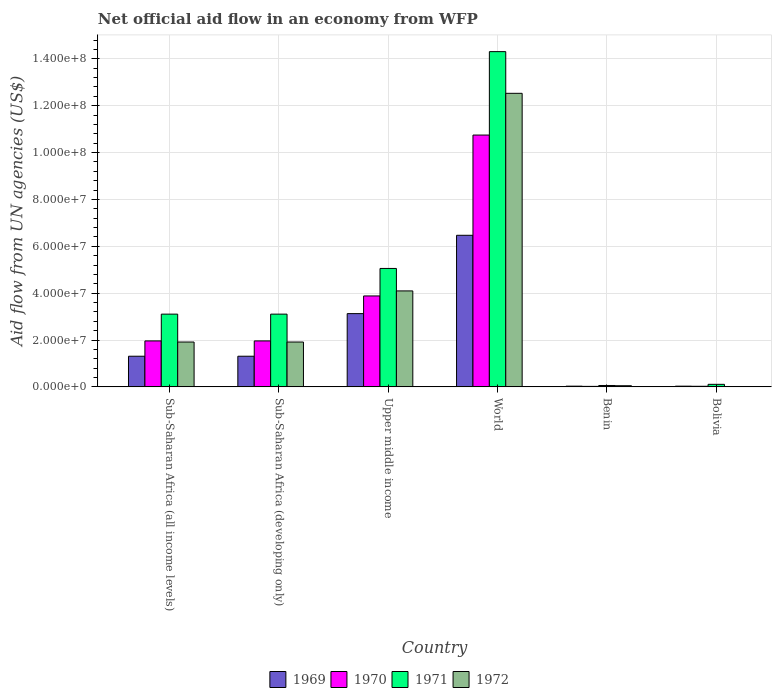How many different coloured bars are there?
Keep it short and to the point. 4. How many groups of bars are there?
Offer a very short reply. 6. Are the number of bars per tick equal to the number of legend labels?
Offer a terse response. No. What is the label of the 2nd group of bars from the left?
Offer a terse response. Sub-Saharan Africa (developing only). What is the net official aid flow in 1970 in Upper middle income?
Ensure brevity in your answer.  3.88e+07. Across all countries, what is the maximum net official aid flow in 1970?
Offer a very short reply. 1.07e+08. In which country was the net official aid flow in 1970 maximum?
Provide a succinct answer. World. What is the total net official aid flow in 1970 in the graph?
Provide a short and direct response. 1.86e+08. What is the difference between the net official aid flow in 1970 in Sub-Saharan Africa (developing only) and that in Upper middle income?
Ensure brevity in your answer.  -1.92e+07. What is the difference between the net official aid flow in 1972 in Benin and the net official aid flow in 1971 in Upper middle income?
Your answer should be compact. -5.00e+07. What is the average net official aid flow in 1969 per country?
Offer a very short reply. 2.05e+07. What is the difference between the net official aid flow of/in 1971 and net official aid flow of/in 1972 in Benin?
Give a very brief answer. 1.00e+05. What is the ratio of the net official aid flow in 1969 in Bolivia to that in Sub-Saharan Africa (all income levels)?
Provide a short and direct response. 0.02. Is the difference between the net official aid flow in 1971 in Benin and World greater than the difference between the net official aid flow in 1972 in Benin and World?
Ensure brevity in your answer.  No. What is the difference between the highest and the second highest net official aid flow in 1969?
Your answer should be very brief. 3.34e+07. What is the difference between the highest and the lowest net official aid flow in 1972?
Ensure brevity in your answer.  1.25e+08. Is the sum of the net official aid flow in 1969 in Benin and World greater than the maximum net official aid flow in 1972 across all countries?
Ensure brevity in your answer.  No. Is it the case that in every country, the sum of the net official aid flow in 1971 and net official aid flow in 1972 is greater than the sum of net official aid flow in 1969 and net official aid flow in 1970?
Your response must be concise. No. How many bars are there?
Offer a very short reply. 23. Are all the bars in the graph horizontal?
Offer a terse response. No. How many countries are there in the graph?
Offer a terse response. 6. What is the difference between two consecutive major ticks on the Y-axis?
Your answer should be compact. 2.00e+07. Are the values on the major ticks of Y-axis written in scientific E-notation?
Offer a terse response. Yes. Does the graph contain any zero values?
Keep it short and to the point. Yes. What is the title of the graph?
Keep it short and to the point. Net official aid flow in an economy from WFP. Does "1978" appear as one of the legend labels in the graph?
Your answer should be compact. No. What is the label or title of the X-axis?
Keep it short and to the point. Country. What is the label or title of the Y-axis?
Provide a short and direct response. Aid flow from UN agencies (US$). What is the Aid flow from UN agencies (US$) in 1969 in Sub-Saharan Africa (all income levels)?
Provide a succinct answer. 1.31e+07. What is the Aid flow from UN agencies (US$) of 1970 in Sub-Saharan Africa (all income levels)?
Make the answer very short. 1.96e+07. What is the Aid flow from UN agencies (US$) in 1971 in Sub-Saharan Africa (all income levels)?
Your answer should be compact. 3.10e+07. What is the Aid flow from UN agencies (US$) of 1972 in Sub-Saharan Africa (all income levels)?
Provide a succinct answer. 1.91e+07. What is the Aid flow from UN agencies (US$) of 1969 in Sub-Saharan Africa (developing only)?
Make the answer very short. 1.31e+07. What is the Aid flow from UN agencies (US$) in 1970 in Sub-Saharan Africa (developing only)?
Your response must be concise. 1.96e+07. What is the Aid flow from UN agencies (US$) of 1971 in Sub-Saharan Africa (developing only)?
Provide a succinct answer. 3.10e+07. What is the Aid flow from UN agencies (US$) in 1972 in Sub-Saharan Africa (developing only)?
Ensure brevity in your answer.  1.91e+07. What is the Aid flow from UN agencies (US$) in 1969 in Upper middle income?
Your answer should be very brief. 3.13e+07. What is the Aid flow from UN agencies (US$) in 1970 in Upper middle income?
Your answer should be compact. 3.88e+07. What is the Aid flow from UN agencies (US$) in 1971 in Upper middle income?
Offer a very short reply. 5.05e+07. What is the Aid flow from UN agencies (US$) in 1972 in Upper middle income?
Provide a succinct answer. 4.10e+07. What is the Aid flow from UN agencies (US$) of 1969 in World?
Offer a very short reply. 6.47e+07. What is the Aid flow from UN agencies (US$) in 1970 in World?
Your answer should be compact. 1.07e+08. What is the Aid flow from UN agencies (US$) in 1971 in World?
Give a very brief answer. 1.43e+08. What is the Aid flow from UN agencies (US$) in 1972 in World?
Your answer should be compact. 1.25e+08. What is the Aid flow from UN agencies (US$) of 1971 in Benin?
Keep it short and to the point. 5.90e+05. What is the Aid flow from UN agencies (US$) of 1969 in Bolivia?
Make the answer very short. 3.00e+05. What is the Aid flow from UN agencies (US$) in 1970 in Bolivia?
Keep it short and to the point. 2.50e+05. What is the Aid flow from UN agencies (US$) of 1971 in Bolivia?
Provide a succinct answer. 1.08e+06. Across all countries, what is the maximum Aid flow from UN agencies (US$) in 1969?
Your answer should be compact. 6.47e+07. Across all countries, what is the maximum Aid flow from UN agencies (US$) in 1970?
Your answer should be compact. 1.07e+08. Across all countries, what is the maximum Aid flow from UN agencies (US$) of 1971?
Your answer should be very brief. 1.43e+08. Across all countries, what is the maximum Aid flow from UN agencies (US$) of 1972?
Keep it short and to the point. 1.25e+08. Across all countries, what is the minimum Aid flow from UN agencies (US$) in 1971?
Your response must be concise. 5.90e+05. What is the total Aid flow from UN agencies (US$) of 1969 in the graph?
Give a very brief answer. 1.23e+08. What is the total Aid flow from UN agencies (US$) of 1970 in the graph?
Your answer should be compact. 1.86e+08. What is the total Aid flow from UN agencies (US$) in 1971 in the graph?
Keep it short and to the point. 2.57e+08. What is the total Aid flow from UN agencies (US$) in 1972 in the graph?
Provide a succinct answer. 2.05e+08. What is the difference between the Aid flow from UN agencies (US$) of 1970 in Sub-Saharan Africa (all income levels) and that in Sub-Saharan Africa (developing only)?
Make the answer very short. 0. What is the difference between the Aid flow from UN agencies (US$) in 1971 in Sub-Saharan Africa (all income levels) and that in Sub-Saharan Africa (developing only)?
Keep it short and to the point. 0. What is the difference between the Aid flow from UN agencies (US$) of 1969 in Sub-Saharan Africa (all income levels) and that in Upper middle income?
Ensure brevity in your answer.  -1.82e+07. What is the difference between the Aid flow from UN agencies (US$) in 1970 in Sub-Saharan Africa (all income levels) and that in Upper middle income?
Offer a terse response. -1.92e+07. What is the difference between the Aid flow from UN agencies (US$) in 1971 in Sub-Saharan Africa (all income levels) and that in Upper middle income?
Your answer should be compact. -1.95e+07. What is the difference between the Aid flow from UN agencies (US$) of 1972 in Sub-Saharan Africa (all income levels) and that in Upper middle income?
Make the answer very short. -2.18e+07. What is the difference between the Aid flow from UN agencies (US$) of 1969 in Sub-Saharan Africa (all income levels) and that in World?
Give a very brief answer. -5.16e+07. What is the difference between the Aid flow from UN agencies (US$) in 1970 in Sub-Saharan Africa (all income levels) and that in World?
Provide a succinct answer. -8.78e+07. What is the difference between the Aid flow from UN agencies (US$) of 1971 in Sub-Saharan Africa (all income levels) and that in World?
Your answer should be very brief. -1.12e+08. What is the difference between the Aid flow from UN agencies (US$) of 1972 in Sub-Saharan Africa (all income levels) and that in World?
Provide a succinct answer. -1.06e+08. What is the difference between the Aid flow from UN agencies (US$) of 1969 in Sub-Saharan Africa (all income levels) and that in Benin?
Keep it short and to the point. 1.28e+07. What is the difference between the Aid flow from UN agencies (US$) of 1970 in Sub-Saharan Africa (all income levels) and that in Benin?
Keep it short and to the point. 1.94e+07. What is the difference between the Aid flow from UN agencies (US$) in 1971 in Sub-Saharan Africa (all income levels) and that in Benin?
Ensure brevity in your answer.  3.04e+07. What is the difference between the Aid flow from UN agencies (US$) in 1972 in Sub-Saharan Africa (all income levels) and that in Benin?
Provide a succinct answer. 1.86e+07. What is the difference between the Aid flow from UN agencies (US$) of 1969 in Sub-Saharan Africa (all income levels) and that in Bolivia?
Provide a succinct answer. 1.28e+07. What is the difference between the Aid flow from UN agencies (US$) in 1970 in Sub-Saharan Africa (all income levels) and that in Bolivia?
Give a very brief answer. 1.94e+07. What is the difference between the Aid flow from UN agencies (US$) in 1971 in Sub-Saharan Africa (all income levels) and that in Bolivia?
Your answer should be very brief. 3.00e+07. What is the difference between the Aid flow from UN agencies (US$) in 1969 in Sub-Saharan Africa (developing only) and that in Upper middle income?
Keep it short and to the point. -1.82e+07. What is the difference between the Aid flow from UN agencies (US$) in 1970 in Sub-Saharan Africa (developing only) and that in Upper middle income?
Offer a terse response. -1.92e+07. What is the difference between the Aid flow from UN agencies (US$) of 1971 in Sub-Saharan Africa (developing only) and that in Upper middle income?
Provide a short and direct response. -1.95e+07. What is the difference between the Aid flow from UN agencies (US$) of 1972 in Sub-Saharan Africa (developing only) and that in Upper middle income?
Your answer should be very brief. -2.18e+07. What is the difference between the Aid flow from UN agencies (US$) in 1969 in Sub-Saharan Africa (developing only) and that in World?
Your answer should be compact. -5.16e+07. What is the difference between the Aid flow from UN agencies (US$) in 1970 in Sub-Saharan Africa (developing only) and that in World?
Offer a terse response. -8.78e+07. What is the difference between the Aid flow from UN agencies (US$) of 1971 in Sub-Saharan Africa (developing only) and that in World?
Provide a succinct answer. -1.12e+08. What is the difference between the Aid flow from UN agencies (US$) in 1972 in Sub-Saharan Africa (developing only) and that in World?
Ensure brevity in your answer.  -1.06e+08. What is the difference between the Aid flow from UN agencies (US$) in 1969 in Sub-Saharan Africa (developing only) and that in Benin?
Offer a very short reply. 1.28e+07. What is the difference between the Aid flow from UN agencies (US$) in 1970 in Sub-Saharan Africa (developing only) and that in Benin?
Offer a terse response. 1.94e+07. What is the difference between the Aid flow from UN agencies (US$) of 1971 in Sub-Saharan Africa (developing only) and that in Benin?
Your answer should be compact. 3.04e+07. What is the difference between the Aid flow from UN agencies (US$) of 1972 in Sub-Saharan Africa (developing only) and that in Benin?
Keep it short and to the point. 1.86e+07. What is the difference between the Aid flow from UN agencies (US$) of 1969 in Sub-Saharan Africa (developing only) and that in Bolivia?
Provide a succinct answer. 1.28e+07. What is the difference between the Aid flow from UN agencies (US$) of 1970 in Sub-Saharan Africa (developing only) and that in Bolivia?
Make the answer very short. 1.94e+07. What is the difference between the Aid flow from UN agencies (US$) in 1971 in Sub-Saharan Africa (developing only) and that in Bolivia?
Ensure brevity in your answer.  3.00e+07. What is the difference between the Aid flow from UN agencies (US$) of 1969 in Upper middle income and that in World?
Give a very brief answer. -3.34e+07. What is the difference between the Aid flow from UN agencies (US$) in 1970 in Upper middle income and that in World?
Provide a short and direct response. -6.87e+07. What is the difference between the Aid flow from UN agencies (US$) of 1971 in Upper middle income and that in World?
Provide a succinct answer. -9.25e+07. What is the difference between the Aid flow from UN agencies (US$) in 1972 in Upper middle income and that in World?
Offer a very short reply. -8.43e+07. What is the difference between the Aid flow from UN agencies (US$) in 1969 in Upper middle income and that in Benin?
Keep it short and to the point. 3.10e+07. What is the difference between the Aid flow from UN agencies (US$) of 1970 in Upper middle income and that in Benin?
Give a very brief answer. 3.86e+07. What is the difference between the Aid flow from UN agencies (US$) of 1971 in Upper middle income and that in Benin?
Your response must be concise. 5.00e+07. What is the difference between the Aid flow from UN agencies (US$) of 1972 in Upper middle income and that in Benin?
Ensure brevity in your answer.  4.05e+07. What is the difference between the Aid flow from UN agencies (US$) in 1969 in Upper middle income and that in Bolivia?
Your response must be concise. 3.10e+07. What is the difference between the Aid flow from UN agencies (US$) of 1970 in Upper middle income and that in Bolivia?
Your answer should be compact. 3.86e+07. What is the difference between the Aid flow from UN agencies (US$) in 1971 in Upper middle income and that in Bolivia?
Provide a short and direct response. 4.95e+07. What is the difference between the Aid flow from UN agencies (US$) of 1969 in World and that in Benin?
Provide a short and direct response. 6.44e+07. What is the difference between the Aid flow from UN agencies (US$) in 1970 in World and that in Benin?
Give a very brief answer. 1.07e+08. What is the difference between the Aid flow from UN agencies (US$) in 1971 in World and that in Benin?
Offer a very short reply. 1.42e+08. What is the difference between the Aid flow from UN agencies (US$) of 1972 in World and that in Benin?
Ensure brevity in your answer.  1.25e+08. What is the difference between the Aid flow from UN agencies (US$) of 1969 in World and that in Bolivia?
Give a very brief answer. 6.44e+07. What is the difference between the Aid flow from UN agencies (US$) of 1970 in World and that in Bolivia?
Your answer should be compact. 1.07e+08. What is the difference between the Aid flow from UN agencies (US$) of 1971 in World and that in Bolivia?
Provide a succinct answer. 1.42e+08. What is the difference between the Aid flow from UN agencies (US$) of 1970 in Benin and that in Bolivia?
Keep it short and to the point. -4.00e+04. What is the difference between the Aid flow from UN agencies (US$) of 1971 in Benin and that in Bolivia?
Keep it short and to the point. -4.90e+05. What is the difference between the Aid flow from UN agencies (US$) of 1969 in Sub-Saharan Africa (all income levels) and the Aid flow from UN agencies (US$) of 1970 in Sub-Saharan Africa (developing only)?
Your response must be concise. -6.53e+06. What is the difference between the Aid flow from UN agencies (US$) in 1969 in Sub-Saharan Africa (all income levels) and the Aid flow from UN agencies (US$) in 1971 in Sub-Saharan Africa (developing only)?
Give a very brief answer. -1.80e+07. What is the difference between the Aid flow from UN agencies (US$) of 1969 in Sub-Saharan Africa (all income levels) and the Aid flow from UN agencies (US$) of 1972 in Sub-Saharan Africa (developing only)?
Make the answer very short. -6.06e+06. What is the difference between the Aid flow from UN agencies (US$) in 1970 in Sub-Saharan Africa (all income levels) and the Aid flow from UN agencies (US$) in 1971 in Sub-Saharan Africa (developing only)?
Make the answer very short. -1.14e+07. What is the difference between the Aid flow from UN agencies (US$) of 1971 in Sub-Saharan Africa (all income levels) and the Aid flow from UN agencies (US$) of 1972 in Sub-Saharan Africa (developing only)?
Give a very brief answer. 1.19e+07. What is the difference between the Aid flow from UN agencies (US$) of 1969 in Sub-Saharan Africa (all income levels) and the Aid flow from UN agencies (US$) of 1970 in Upper middle income?
Provide a succinct answer. -2.57e+07. What is the difference between the Aid flow from UN agencies (US$) of 1969 in Sub-Saharan Africa (all income levels) and the Aid flow from UN agencies (US$) of 1971 in Upper middle income?
Your response must be concise. -3.75e+07. What is the difference between the Aid flow from UN agencies (US$) of 1969 in Sub-Saharan Africa (all income levels) and the Aid flow from UN agencies (US$) of 1972 in Upper middle income?
Ensure brevity in your answer.  -2.79e+07. What is the difference between the Aid flow from UN agencies (US$) in 1970 in Sub-Saharan Africa (all income levels) and the Aid flow from UN agencies (US$) in 1971 in Upper middle income?
Your answer should be compact. -3.09e+07. What is the difference between the Aid flow from UN agencies (US$) of 1970 in Sub-Saharan Africa (all income levels) and the Aid flow from UN agencies (US$) of 1972 in Upper middle income?
Offer a very short reply. -2.13e+07. What is the difference between the Aid flow from UN agencies (US$) of 1971 in Sub-Saharan Africa (all income levels) and the Aid flow from UN agencies (US$) of 1972 in Upper middle income?
Your response must be concise. -9.91e+06. What is the difference between the Aid flow from UN agencies (US$) of 1969 in Sub-Saharan Africa (all income levels) and the Aid flow from UN agencies (US$) of 1970 in World?
Provide a succinct answer. -9.44e+07. What is the difference between the Aid flow from UN agencies (US$) of 1969 in Sub-Saharan Africa (all income levels) and the Aid flow from UN agencies (US$) of 1971 in World?
Offer a terse response. -1.30e+08. What is the difference between the Aid flow from UN agencies (US$) in 1969 in Sub-Saharan Africa (all income levels) and the Aid flow from UN agencies (US$) in 1972 in World?
Keep it short and to the point. -1.12e+08. What is the difference between the Aid flow from UN agencies (US$) in 1970 in Sub-Saharan Africa (all income levels) and the Aid flow from UN agencies (US$) in 1971 in World?
Make the answer very short. -1.23e+08. What is the difference between the Aid flow from UN agencies (US$) in 1970 in Sub-Saharan Africa (all income levels) and the Aid flow from UN agencies (US$) in 1972 in World?
Offer a terse response. -1.06e+08. What is the difference between the Aid flow from UN agencies (US$) in 1971 in Sub-Saharan Africa (all income levels) and the Aid flow from UN agencies (US$) in 1972 in World?
Give a very brief answer. -9.42e+07. What is the difference between the Aid flow from UN agencies (US$) in 1969 in Sub-Saharan Africa (all income levels) and the Aid flow from UN agencies (US$) in 1970 in Benin?
Provide a succinct answer. 1.29e+07. What is the difference between the Aid flow from UN agencies (US$) in 1969 in Sub-Saharan Africa (all income levels) and the Aid flow from UN agencies (US$) in 1971 in Benin?
Your answer should be very brief. 1.25e+07. What is the difference between the Aid flow from UN agencies (US$) in 1969 in Sub-Saharan Africa (all income levels) and the Aid flow from UN agencies (US$) in 1972 in Benin?
Make the answer very short. 1.26e+07. What is the difference between the Aid flow from UN agencies (US$) of 1970 in Sub-Saharan Africa (all income levels) and the Aid flow from UN agencies (US$) of 1971 in Benin?
Your answer should be compact. 1.90e+07. What is the difference between the Aid flow from UN agencies (US$) of 1970 in Sub-Saharan Africa (all income levels) and the Aid flow from UN agencies (US$) of 1972 in Benin?
Give a very brief answer. 1.91e+07. What is the difference between the Aid flow from UN agencies (US$) of 1971 in Sub-Saharan Africa (all income levels) and the Aid flow from UN agencies (US$) of 1972 in Benin?
Keep it short and to the point. 3.06e+07. What is the difference between the Aid flow from UN agencies (US$) in 1969 in Sub-Saharan Africa (all income levels) and the Aid flow from UN agencies (US$) in 1970 in Bolivia?
Your answer should be very brief. 1.28e+07. What is the difference between the Aid flow from UN agencies (US$) of 1970 in Sub-Saharan Africa (all income levels) and the Aid flow from UN agencies (US$) of 1971 in Bolivia?
Make the answer very short. 1.85e+07. What is the difference between the Aid flow from UN agencies (US$) in 1969 in Sub-Saharan Africa (developing only) and the Aid flow from UN agencies (US$) in 1970 in Upper middle income?
Make the answer very short. -2.57e+07. What is the difference between the Aid flow from UN agencies (US$) of 1969 in Sub-Saharan Africa (developing only) and the Aid flow from UN agencies (US$) of 1971 in Upper middle income?
Your response must be concise. -3.75e+07. What is the difference between the Aid flow from UN agencies (US$) in 1969 in Sub-Saharan Africa (developing only) and the Aid flow from UN agencies (US$) in 1972 in Upper middle income?
Keep it short and to the point. -2.79e+07. What is the difference between the Aid flow from UN agencies (US$) in 1970 in Sub-Saharan Africa (developing only) and the Aid flow from UN agencies (US$) in 1971 in Upper middle income?
Your response must be concise. -3.09e+07. What is the difference between the Aid flow from UN agencies (US$) of 1970 in Sub-Saharan Africa (developing only) and the Aid flow from UN agencies (US$) of 1972 in Upper middle income?
Give a very brief answer. -2.13e+07. What is the difference between the Aid flow from UN agencies (US$) in 1971 in Sub-Saharan Africa (developing only) and the Aid flow from UN agencies (US$) in 1972 in Upper middle income?
Offer a very short reply. -9.91e+06. What is the difference between the Aid flow from UN agencies (US$) in 1969 in Sub-Saharan Africa (developing only) and the Aid flow from UN agencies (US$) in 1970 in World?
Your answer should be compact. -9.44e+07. What is the difference between the Aid flow from UN agencies (US$) of 1969 in Sub-Saharan Africa (developing only) and the Aid flow from UN agencies (US$) of 1971 in World?
Keep it short and to the point. -1.30e+08. What is the difference between the Aid flow from UN agencies (US$) in 1969 in Sub-Saharan Africa (developing only) and the Aid flow from UN agencies (US$) in 1972 in World?
Offer a terse response. -1.12e+08. What is the difference between the Aid flow from UN agencies (US$) of 1970 in Sub-Saharan Africa (developing only) and the Aid flow from UN agencies (US$) of 1971 in World?
Give a very brief answer. -1.23e+08. What is the difference between the Aid flow from UN agencies (US$) of 1970 in Sub-Saharan Africa (developing only) and the Aid flow from UN agencies (US$) of 1972 in World?
Make the answer very short. -1.06e+08. What is the difference between the Aid flow from UN agencies (US$) of 1971 in Sub-Saharan Africa (developing only) and the Aid flow from UN agencies (US$) of 1972 in World?
Offer a very short reply. -9.42e+07. What is the difference between the Aid flow from UN agencies (US$) of 1969 in Sub-Saharan Africa (developing only) and the Aid flow from UN agencies (US$) of 1970 in Benin?
Ensure brevity in your answer.  1.29e+07. What is the difference between the Aid flow from UN agencies (US$) of 1969 in Sub-Saharan Africa (developing only) and the Aid flow from UN agencies (US$) of 1971 in Benin?
Make the answer very short. 1.25e+07. What is the difference between the Aid flow from UN agencies (US$) in 1969 in Sub-Saharan Africa (developing only) and the Aid flow from UN agencies (US$) in 1972 in Benin?
Offer a very short reply. 1.26e+07. What is the difference between the Aid flow from UN agencies (US$) in 1970 in Sub-Saharan Africa (developing only) and the Aid flow from UN agencies (US$) in 1971 in Benin?
Offer a terse response. 1.90e+07. What is the difference between the Aid flow from UN agencies (US$) of 1970 in Sub-Saharan Africa (developing only) and the Aid flow from UN agencies (US$) of 1972 in Benin?
Provide a short and direct response. 1.91e+07. What is the difference between the Aid flow from UN agencies (US$) in 1971 in Sub-Saharan Africa (developing only) and the Aid flow from UN agencies (US$) in 1972 in Benin?
Give a very brief answer. 3.06e+07. What is the difference between the Aid flow from UN agencies (US$) of 1969 in Sub-Saharan Africa (developing only) and the Aid flow from UN agencies (US$) of 1970 in Bolivia?
Your answer should be very brief. 1.28e+07. What is the difference between the Aid flow from UN agencies (US$) of 1970 in Sub-Saharan Africa (developing only) and the Aid flow from UN agencies (US$) of 1971 in Bolivia?
Offer a very short reply. 1.85e+07. What is the difference between the Aid flow from UN agencies (US$) in 1969 in Upper middle income and the Aid flow from UN agencies (US$) in 1970 in World?
Ensure brevity in your answer.  -7.62e+07. What is the difference between the Aid flow from UN agencies (US$) of 1969 in Upper middle income and the Aid flow from UN agencies (US$) of 1971 in World?
Provide a short and direct response. -1.12e+08. What is the difference between the Aid flow from UN agencies (US$) in 1969 in Upper middle income and the Aid flow from UN agencies (US$) in 1972 in World?
Make the answer very short. -9.40e+07. What is the difference between the Aid flow from UN agencies (US$) of 1970 in Upper middle income and the Aid flow from UN agencies (US$) of 1971 in World?
Ensure brevity in your answer.  -1.04e+08. What is the difference between the Aid flow from UN agencies (US$) of 1970 in Upper middle income and the Aid flow from UN agencies (US$) of 1972 in World?
Your answer should be very brief. -8.65e+07. What is the difference between the Aid flow from UN agencies (US$) in 1971 in Upper middle income and the Aid flow from UN agencies (US$) in 1972 in World?
Give a very brief answer. -7.47e+07. What is the difference between the Aid flow from UN agencies (US$) of 1969 in Upper middle income and the Aid flow from UN agencies (US$) of 1970 in Benin?
Provide a short and direct response. 3.10e+07. What is the difference between the Aid flow from UN agencies (US$) of 1969 in Upper middle income and the Aid flow from UN agencies (US$) of 1971 in Benin?
Ensure brevity in your answer.  3.07e+07. What is the difference between the Aid flow from UN agencies (US$) in 1969 in Upper middle income and the Aid flow from UN agencies (US$) in 1972 in Benin?
Keep it short and to the point. 3.08e+07. What is the difference between the Aid flow from UN agencies (US$) in 1970 in Upper middle income and the Aid flow from UN agencies (US$) in 1971 in Benin?
Your answer should be very brief. 3.82e+07. What is the difference between the Aid flow from UN agencies (US$) in 1970 in Upper middle income and the Aid flow from UN agencies (US$) in 1972 in Benin?
Ensure brevity in your answer.  3.83e+07. What is the difference between the Aid flow from UN agencies (US$) in 1971 in Upper middle income and the Aid flow from UN agencies (US$) in 1972 in Benin?
Keep it short and to the point. 5.00e+07. What is the difference between the Aid flow from UN agencies (US$) of 1969 in Upper middle income and the Aid flow from UN agencies (US$) of 1970 in Bolivia?
Provide a short and direct response. 3.10e+07. What is the difference between the Aid flow from UN agencies (US$) of 1969 in Upper middle income and the Aid flow from UN agencies (US$) of 1971 in Bolivia?
Make the answer very short. 3.02e+07. What is the difference between the Aid flow from UN agencies (US$) in 1970 in Upper middle income and the Aid flow from UN agencies (US$) in 1971 in Bolivia?
Your answer should be compact. 3.77e+07. What is the difference between the Aid flow from UN agencies (US$) of 1969 in World and the Aid flow from UN agencies (US$) of 1970 in Benin?
Your response must be concise. 6.45e+07. What is the difference between the Aid flow from UN agencies (US$) of 1969 in World and the Aid flow from UN agencies (US$) of 1971 in Benin?
Your answer should be compact. 6.41e+07. What is the difference between the Aid flow from UN agencies (US$) of 1969 in World and the Aid flow from UN agencies (US$) of 1972 in Benin?
Give a very brief answer. 6.42e+07. What is the difference between the Aid flow from UN agencies (US$) in 1970 in World and the Aid flow from UN agencies (US$) in 1971 in Benin?
Your response must be concise. 1.07e+08. What is the difference between the Aid flow from UN agencies (US$) of 1970 in World and the Aid flow from UN agencies (US$) of 1972 in Benin?
Your answer should be compact. 1.07e+08. What is the difference between the Aid flow from UN agencies (US$) in 1971 in World and the Aid flow from UN agencies (US$) in 1972 in Benin?
Provide a succinct answer. 1.43e+08. What is the difference between the Aid flow from UN agencies (US$) in 1969 in World and the Aid flow from UN agencies (US$) in 1970 in Bolivia?
Your response must be concise. 6.44e+07. What is the difference between the Aid flow from UN agencies (US$) of 1969 in World and the Aid flow from UN agencies (US$) of 1971 in Bolivia?
Give a very brief answer. 6.36e+07. What is the difference between the Aid flow from UN agencies (US$) in 1970 in World and the Aid flow from UN agencies (US$) in 1971 in Bolivia?
Your answer should be very brief. 1.06e+08. What is the difference between the Aid flow from UN agencies (US$) in 1969 in Benin and the Aid flow from UN agencies (US$) in 1971 in Bolivia?
Make the answer very short. -7.80e+05. What is the difference between the Aid flow from UN agencies (US$) of 1970 in Benin and the Aid flow from UN agencies (US$) of 1971 in Bolivia?
Your response must be concise. -8.70e+05. What is the average Aid flow from UN agencies (US$) of 1969 per country?
Your response must be concise. 2.05e+07. What is the average Aid flow from UN agencies (US$) of 1970 per country?
Provide a succinct answer. 3.10e+07. What is the average Aid flow from UN agencies (US$) in 1971 per country?
Offer a very short reply. 4.29e+07. What is the average Aid flow from UN agencies (US$) in 1972 per country?
Offer a terse response. 3.42e+07. What is the difference between the Aid flow from UN agencies (US$) of 1969 and Aid flow from UN agencies (US$) of 1970 in Sub-Saharan Africa (all income levels)?
Provide a succinct answer. -6.53e+06. What is the difference between the Aid flow from UN agencies (US$) of 1969 and Aid flow from UN agencies (US$) of 1971 in Sub-Saharan Africa (all income levels)?
Provide a short and direct response. -1.80e+07. What is the difference between the Aid flow from UN agencies (US$) in 1969 and Aid flow from UN agencies (US$) in 1972 in Sub-Saharan Africa (all income levels)?
Your answer should be very brief. -6.06e+06. What is the difference between the Aid flow from UN agencies (US$) in 1970 and Aid flow from UN agencies (US$) in 1971 in Sub-Saharan Africa (all income levels)?
Offer a terse response. -1.14e+07. What is the difference between the Aid flow from UN agencies (US$) of 1970 and Aid flow from UN agencies (US$) of 1972 in Sub-Saharan Africa (all income levels)?
Offer a very short reply. 4.70e+05. What is the difference between the Aid flow from UN agencies (US$) of 1971 and Aid flow from UN agencies (US$) of 1972 in Sub-Saharan Africa (all income levels)?
Provide a short and direct response. 1.19e+07. What is the difference between the Aid flow from UN agencies (US$) of 1969 and Aid flow from UN agencies (US$) of 1970 in Sub-Saharan Africa (developing only)?
Keep it short and to the point. -6.53e+06. What is the difference between the Aid flow from UN agencies (US$) of 1969 and Aid flow from UN agencies (US$) of 1971 in Sub-Saharan Africa (developing only)?
Offer a very short reply. -1.80e+07. What is the difference between the Aid flow from UN agencies (US$) of 1969 and Aid flow from UN agencies (US$) of 1972 in Sub-Saharan Africa (developing only)?
Provide a short and direct response. -6.06e+06. What is the difference between the Aid flow from UN agencies (US$) of 1970 and Aid flow from UN agencies (US$) of 1971 in Sub-Saharan Africa (developing only)?
Keep it short and to the point. -1.14e+07. What is the difference between the Aid flow from UN agencies (US$) in 1970 and Aid flow from UN agencies (US$) in 1972 in Sub-Saharan Africa (developing only)?
Your answer should be very brief. 4.70e+05. What is the difference between the Aid flow from UN agencies (US$) of 1971 and Aid flow from UN agencies (US$) of 1972 in Sub-Saharan Africa (developing only)?
Ensure brevity in your answer.  1.19e+07. What is the difference between the Aid flow from UN agencies (US$) of 1969 and Aid flow from UN agencies (US$) of 1970 in Upper middle income?
Ensure brevity in your answer.  -7.54e+06. What is the difference between the Aid flow from UN agencies (US$) in 1969 and Aid flow from UN agencies (US$) in 1971 in Upper middle income?
Offer a very short reply. -1.93e+07. What is the difference between the Aid flow from UN agencies (US$) in 1969 and Aid flow from UN agencies (US$) in 1972 in Upper middle income?
Keep it short and to the point. -9.69e+06. What is the difference between the Aid flow from UN agencies (US$) of 1970 and Aid flow from UN agencies (US$) of 1971 in Upper middle income?
Offer a very short reply. -1.17e+07. What is the difference between the Aid flow from UN agencies (US$) of 1970 and Aid flow from UN agencies (US$) of 1972 in Upper middle income?
Give a very brief answer. -2.15e+06. What is the difference between the Aid flow from UN agencies (US$) of 1971 and Aid flow from UN agencies (US$) of 1972 in Upper middle income?
Make the answer very short. 9.59e+06. What is the difference between the Aid flow from UN agencies (US$) of 1969 and Aid flow from UN agencies (US$) of 1970 in World?
Your response must be concise. -4.28e+07. What is the difference between the Aid flow from UN agencies (US$) in 1969 and Aid flow from UN agencies (US$) in 1971 in World?
Give a very brief answer. -7.84e+07. What is the difference between the Aid flow from UN agencies (US$) in 1969 and Aid flow from UN agencies (US$) in 1972 in World?
Provide a succinct answer. -6.06e+07. What is the difference between the Aid flow from UN agencies (US$) of 1970 and Aid flow from UN agencies (US$) of 1971 in World?
Provide a short and direct response. -3.56e+07. What is the difference between the Aid flow from UN agencies (US$) in 1970 and Aid flow from UN agencies (US$) in 1972 in World?
Give a very brief answer. -1.78e+07. What is the difference between the Aid flow from UN agencies (US$) of 1971 and Aid flow from UN agencies (US$) of 1972 in World?
Your response must be concise. 1.78e+07. What is the difference between the Aid flow from UN agencies (US$) in 1969 and Aid flow from UN agencies (US$) in 1970 in Benin?
Your answer should be very brief. 9.00e+04. What is the difference between the Aid flow from UN agencies (US$) of 1970 and Aid flow from UN agencies (US$) of 1971 in Benin?
Your response must be concise. -3.80e+05. What is the difference between the Aid flow from UN agencies (US$) in 1970 and Aid flow from UN agencies (US$) in 1972 in Benin?
Make the answer very short. -2.80e+05. What is the difference between the Aid flow from UN agencies (US$) in 1969 and Aid flow from UN agencies (US$) in 1970 in Bolivia?
Provide a short and direct response. 5.00e+04. What is the difference between the Aid flow from UN agencies (US$) of 1969 and Aid flow from UN agencies (US$) of 1971 in Bolivia?
Give a very brief answer. -7.80e+05. What is the difference between the Aid flow from UN agencies (US$) in 1970 and Aid flow from UN agencies (US$) in 1971 in Bolivia?
Provide a succinct answer. -8.30e+05. What is the ratio of the Aid flow from UN agencies (US$) in 1969 in Sub-Saharan Africa (all income levels) to that in Sub-Saharan Africa (developing only)?
Provide a succinct answer. 1. What is the ratio of the Aid flow from UN agencies (US$) in 1969 in Sub-Saharan Africa (all income levels) to that in Upper middle income?
Ensure brevity in your answer.  0.42. What is the ratio of the Aid flow from UN agencies (US$) of 1970 in Sub-Saharan Africa (all income levels) to that in Upper middle income?
Ensure brevity in your answer.  0.51. What is the ratio of the Aid flow from UN agencies (US$) in 1971 in Sub-Saharan Africa (all income levels) to that in Upper middle income?
Your answer should be very brief. 0.61. What is the ratio of the Aid flow from UN agencies (US$) in 1972 in Sub-Saharan Africa (all income levels) to that in Upper middle income?
Offer a terse response. 0.47. What is the ratio of the Aid flow from UN agencies (US$) of 1969 in Sub-Saharan Africa (all income levels) to that in World?
Your answer should be compact. 0.2. What is the ratio of the Aid flow from UN agencies (US$) in 1970 in Sub-Saharan Africa (all income levels) to that in World?
Keep it short and to the point. 0.18. What is the ratio of the Aid flow from UN agencies (US$) of 1971 in Sub-Saharan Africa (all income levels) to that in World?
Your response must be concise. 0.22. What is the ratio of the Aid flow from UN agencies (US$) of 1972 in Sub-Saharan Africa (all income levels) to that in World?
Keep it short and to the point. 0.15. What is the ratio of the Aid flow from UN agencies (US$) of 1969 in Sub-Saharan Africa (all income levels) to that in Benin?
Your response must be concise. 43.6. What is the ratio of the Aid flow from UN agencies (US$) of 1970 in Sub-Saharan Africa (all income levels) to that in Benin?
Your answer should be compact. 93.38. What is the ratio of the Aid flow from UN agencies (US$) of 1971 in Sub-Saharan Africa (all income levels) to that in Benin?
Offer a very short reply. 52.61. What is the ratio of the Aid flow from UN agencies (US$) in 1972 in Sub-Saharan Africa (all income levels) to that in Benin?
Your response must be concise. 39.06. What is the ratio of the Aid flow from UN agencies (US$) of 1969 in Sub-Saharan Africa (all income levels) to that in Bolivia?
Ensure brevity in your answer.  43.6. What is the ratio of the Aid flow from UN agencies (US$) of 1970 in Sub-Saharan Africa (all income levels) to that in Bolivia?
Your response must be concise. 78.44. What is the ratio of the Aid flow from UN agencies (US$) of 1971 in Sub-Saharan Africa (all income levels) to that in Bolivia?
Make the answer very short. 28.74. What is the ratio of the Aid flow from UN agencies (US$) of 1969 in Sub-Saharan Africa (developing only) to that in Upper middle income?
Your response must be concise. 0.42. What is the ratio of the Aid flow from UN agencies (US$) of 1970 in Sub-Saharan Africa (developing only) to that in Upper middle income?
Provide a succinct answer. 0.51. What is the ratio of the Aid flow from UN agencies (US$) in 1971 in Sub-Saharan Africa (developing only) to that in Upper middle income?
Keep it short and to the point. 0.61. What is the ratio of the Aid flow from UN agencies (US$) in 1972 in Sub-Saharan Africa (developing only) to that in Upper middle income?
Keep it short and to the point. 0.47. What is the ratio of the Aid flow from UN agencies (US$) of 1969 in Sub-Saharan Africa (developing only) to that in World?
Ensure brevity in your answer.  0.2. What is the ratio of the Aid flow from UN agencies (US$) in 1970 in Sub-Saharan Africa (developing only) to that in World?
Your response must be concise. 0.18. What is the ratio of the Aid flow from UN agencies (US$) in 1971 in Sub-Saharan Africa (developing only) to that in World?
Ensure brevity in your answer.  0.22. What is the ratio of the Aid flow from UN agencies (US$) of 1972 in Sub-Saharan Africa (developing only) to that in World?
Keep it short and to the point. 0.15. What is the ratio of the Aid flow from UN agencies (US$) in 1969 in Sub-Saharan Africa (developing only) to that in Benin?
Make the answer very short. 43.6. What is the ratio of the Aid flow from UN agencies (US$) in 1970 in Sub-Saharan Africa (developing only) to that in Benin?
Ensure brevity in your answer.  93.38. What is the ratio of the Aid flow from UN agencies (US$) in 1971 in Sub-Saharan Africa (developing only) to that in Benin?
Provide a short and direct response. 52.61. What is the ratio of the Aid flow from UN agencies (US$) of 1972 in Sub-Saharan Africa (developing only) to that in Benin?
Give a very brief answer. 39.06. What is the ratio of the Aid flow from UN agencies (US$) in 1969 in Sub-Saharan Africa (developing only) to that in Bolivia?
Make the answer very short. 43.6. What is the ratio of the Aid flow from UN agencies (US$) in 1970 in Sub-Saharan Africa (developing only) to that in Bolivia?
Keep it short and to the point. 78.44. What is the ratio of the Aid flow from UN agencies (US$) of 1971 in Sub-Saharan Africa (developing only) to that in Bolivia?
Ensure brevity in your answer.  28.74. What is the ratio of the Aid flow from UN agencies (US$) in 1969 in Upper middle income to that in World?
Offer a very short reply. 0.48. What is the ratio of the Aid flow from UN agencies (US$) in 1970 in Upper middle income to that in World?
Provide a short and direct response. 0.36. What is the ratio of the Aid flow from UN agencies (US$) of 1971 in Upper middle income to that in World?
Your response must be concise. 0.35. What is the ratio of the Aid flow from UN agencies (US$) in 1972 in Upper middle income to that in World?
Offer a terse response. 0.33. What is the ratio of the Aid flow from UN agencies (US$) in 1969 in Upper middle income to that in Benin?
Ensure brevity in your answer.  104.2. What is the ratio of the Aid flow from UN agencies (US$) of 1970 in Upper middle income to that in Benin?
Your answer should be very brief. 184.76. What is the ratio of the Aid flow from UN agencies (US$) of 1971 in Upper middle income to that in Benin?
Ensure brevity in your answer.  85.66. What is the ratio of the Aid flow from UN agencies (US$) in 1972 in Upper middle income to that in Benin?
Provide a short and direct response. 83.57. What is the ratio of the Aid flow from UN agencies (US$) of 1969 in Upper middle income to that in Bolivia?
Provide a short and direct response. 104.2. What is the ratio of the Aid flow from UN agencies (US$) in 1970 in Upper middle income to that in Bolivia?
Your answer should be compact. 155.2. What is the ratio of the Aid flow from UN agencies (US$) in 1971 in Upper middle income to that in Bolivia?
Make the answer very short. 46.8. What is the ratio of the Aid flow from UN agencies (US$) of 1969 in World to that in Benin?
Offer a terse response. 215.63. What is the ratio of the Aid flow from UN agencies (US$) of 1970 in World to that in Benin?
Keep it short and to the point. 511.71. What is the ratio of the Aid flow from UN agencies (US$) of 1971 in World to that in Benin?
Provide a succinct answer. 242.47. What is the ratio of the Aid flow from UN agencies (US$) of 1972 in World to that in Benin?
Provide a succinct answer. 255.65. What is the ratio of the Aid flow from UN agencies (US$) of 1969 in World to that in Bolivia?
Make the answer very short. 215.63. What is the ratio of the Aid flow from UN agencies (US$) of 1970 in World to that in Bolivia?
Make the answer very short. 429.84. What is the ratio of the Aid flow from UN agencies (US$) of 1971 in World to that in Bolivia?
Provide a short and direct response. 132.46. What is the ratio of the Aid flow from UN agencies (US$) of 1970 in Benin to that in Bolivia?
Keep it short and to the point. 0.84. What is the ratio of the Aid flow from UN agencies (US$) of 1971 in Benin to that in Bolivia?
Your answer should be compact. 0.55. What is the difference between the highest and the second highest Aid flow from UN agencies (US$) of 1969?
Ensure brevity in your answer.  3.34e+07. What is the difference between the highest and the second highest Aid flow from UN agencies (US$) of 1970?
Keep it short and to the point. 6.87e+07. What is the difference between the highest and the second highest Aid flow from UN agencies (US$) of 1971?
Your response must be concise. 9.25e+07. What is the difference between the highest and the second highest Aid flow from UN agencies (US$) of 1972?
Give a very brief answer. 8.43e+07. What is the difference between the highest and the lowest Aid flow from UN agencies (US$) of 1969?
Give a very brief answer. 6.44e+07. What is the difference between the highest and the lowest Aid flow from UN agencies (US$) of 1970?
Offer a very short reply. 1.07e+08. What is the difference between the highest and the lowest Aid flow from UN agencies (US$) in 1971?
Offer a very short reply. 1.42e+08. What is the difference between the highest and the lowest Aid flow from UN agencies (US$) of 1972?
Make the answer very short. 1.25e+08. 